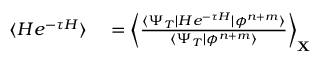Convert formula to latex. <formula><loc_0><loc_0><loc_500><loc_500>\begin{array} { r l } { \langle H e ^ { - \tau H } \rangle } & = \left \langle \frac { \langle \Psi _ { T } | H e ^ { - \tau H } | \phi ^ { n + m } \rangle } { \langle \Psi _ { T } | \phi ^ { n + m } \rangle } \right \rangle _ { \mathbf X } } \end{array}</formula> 